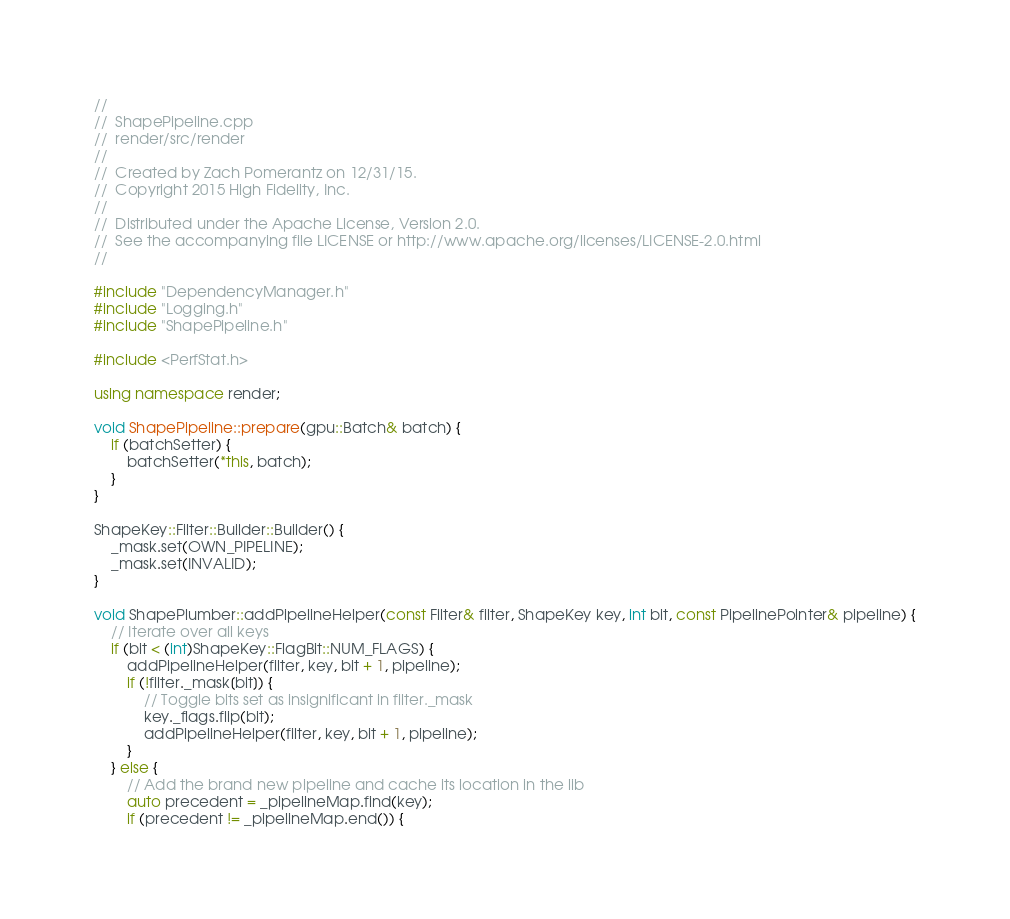Convert code to text. <code><loc_0><loc_0><loc_500><loc_500><_C++_>//
//  ShapePipeline.cpp
//  render/src/render
//
//  Created by Zach Pomerantz on 12/31/15.
//  Copyright 2015 High Fidelity, Inc.
//
//  Distributed under the Apache License, Version 2.0.
//  See the accompanying file LICENSE or http://www.apache.org/licenses/LICENSE-2.0.html
//

#include "DependencyManager.h"
#include "Logging.h"
#include "ShapePipeline.h"

#include <PerfStat.h>

using namespace render;

void ShapePipeline::prepare(gpu::Batch& batch) {
    if (batchSetter) {
        batchSetter(*this, batch);
    }
}

ShapeKey::Filter::Builder::Builder() {
    _mask.set(OWN_PIPELINE);
    _mask.set(INVALID);
}

void ShapePlumber::addPipelineHelper(const Filter& filter, ShapeKey key, int bit, const PipelinePointer& pipeline) {
    // Iterate over all keys
    if (bit < (int)ShapeKey::FlagBit::NUM_FLAGS) {
        addPipelineHelper(filter, key, bit + 1, pipeline);
        if (!filter._mask[bit]) {
            // Toggle bits set as insignificant in filter._mask 
            key._flags.flip(bit);
            addPipelineHelper(filter, key, bit + 1, pipeline);
        }
    } else {
        // Add the brand new pipeline and cache its location in the lib
        auto precedent = _pipelineMap.find(key);
        if (precedent != _pipelineMap.end()) {</code> 